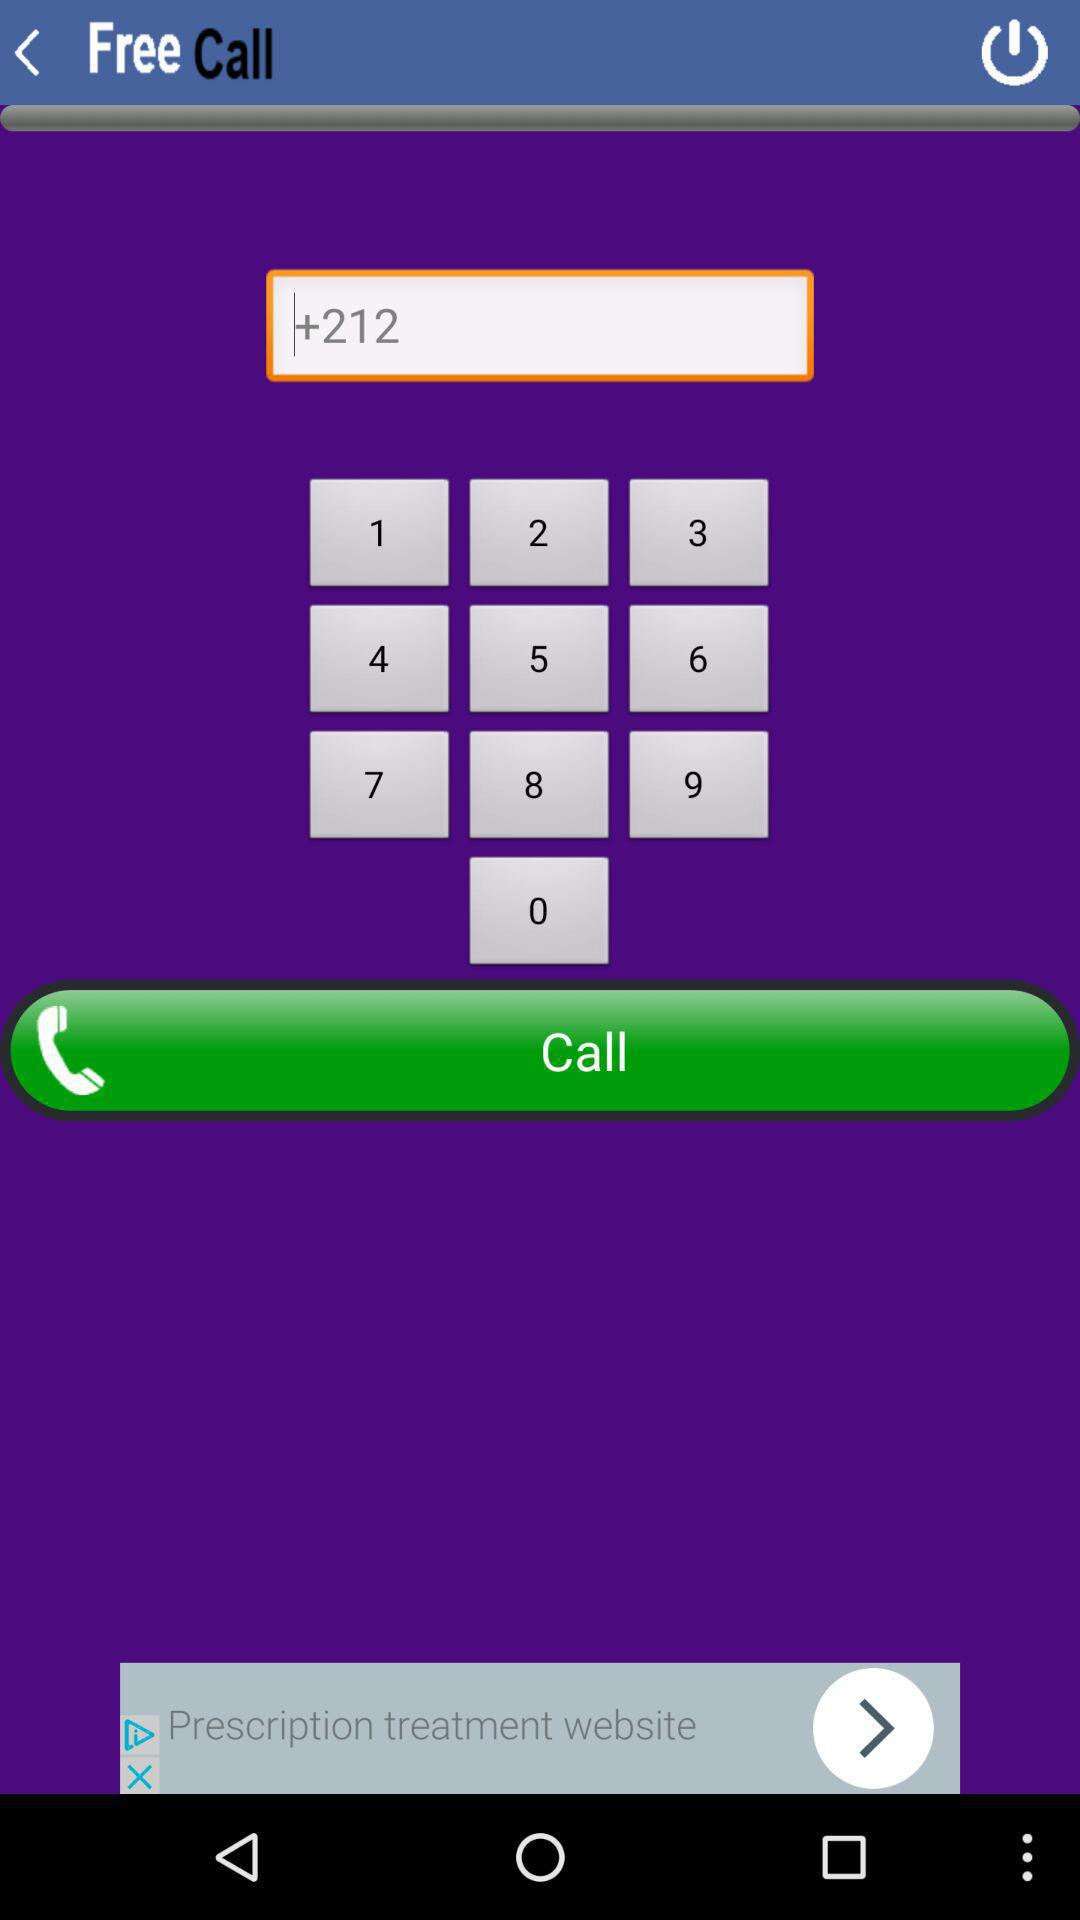What is the entered number? The entered number is +212. 